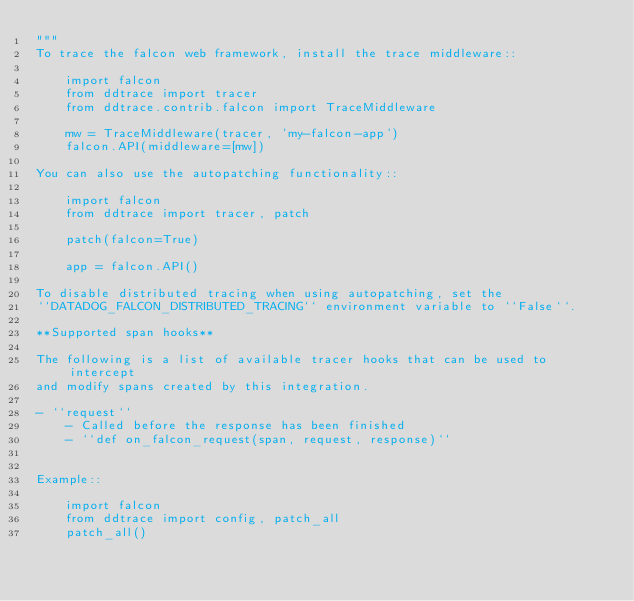Convert code to text. <code><loc_0><loc_0><loc_500><loc_500><_Python_>"""
To trace the falcon web framework, install the trace middleware::

    import falcon
    from ddtrace import tracer
    from ddtrace.contrib.falcon import TraceMiddleware

    mw = TraceMiddleware(tracer, 'my-falcon-app')
    falcon.API(middleware=[mw])

You can also use the autopatching functionality::

    import falcon
    from ddtrace import tracer, patch

    patch(falcon=True)

    app = falcon.API()

To disable distributed tracing when using autopatching, set the
``DATADOG_FALCON_DISTRIBUTED_TRACING`` environment variable to ``False``.

**Supported span hooks**

The following is a list of available tracer hooks that can be used to intercept
and modify spans created by this integration.

- ``request``
    - Called before the response has been finished
    - ``def on_falcon_request(span, request, response)``


Example::

    import falcon
    from ddtrace import config, patch_all
    patch_all()
</code> 